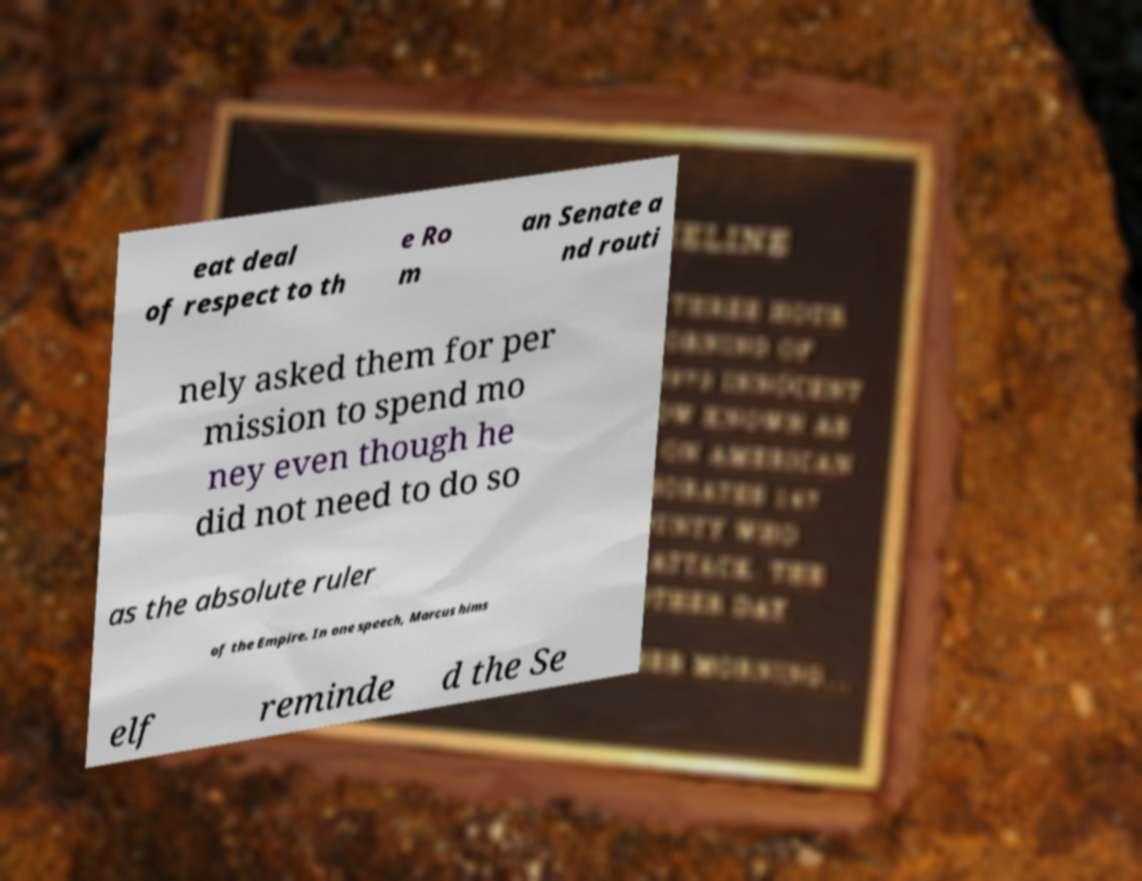Could you extract and type out the text from this image? eat deal of respect to th e Ro m an Senate a nd routi nely asked them for per mission to spend mo ney even though he did not need to do so as the absolute ruler of the Empire. In one speech, Marcus hims elf reminde d the Se 